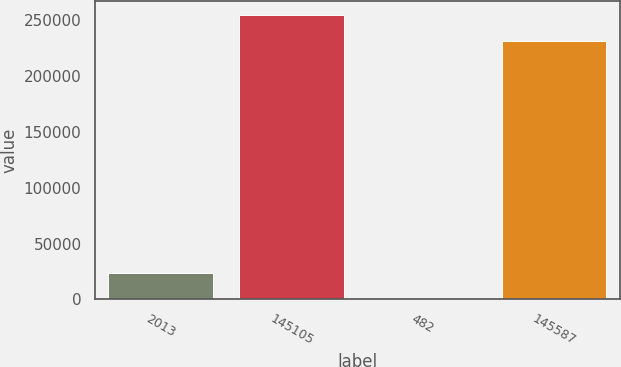<chart> <loc_0><loc_0><loc_500><loc_500><bar_chart><fcel>2013<fcel>145105<fcel>482<fcel>145587<nl><fcel>23573.6<fcel>254569<fcel>431<fcel>231426<nl></chart> 